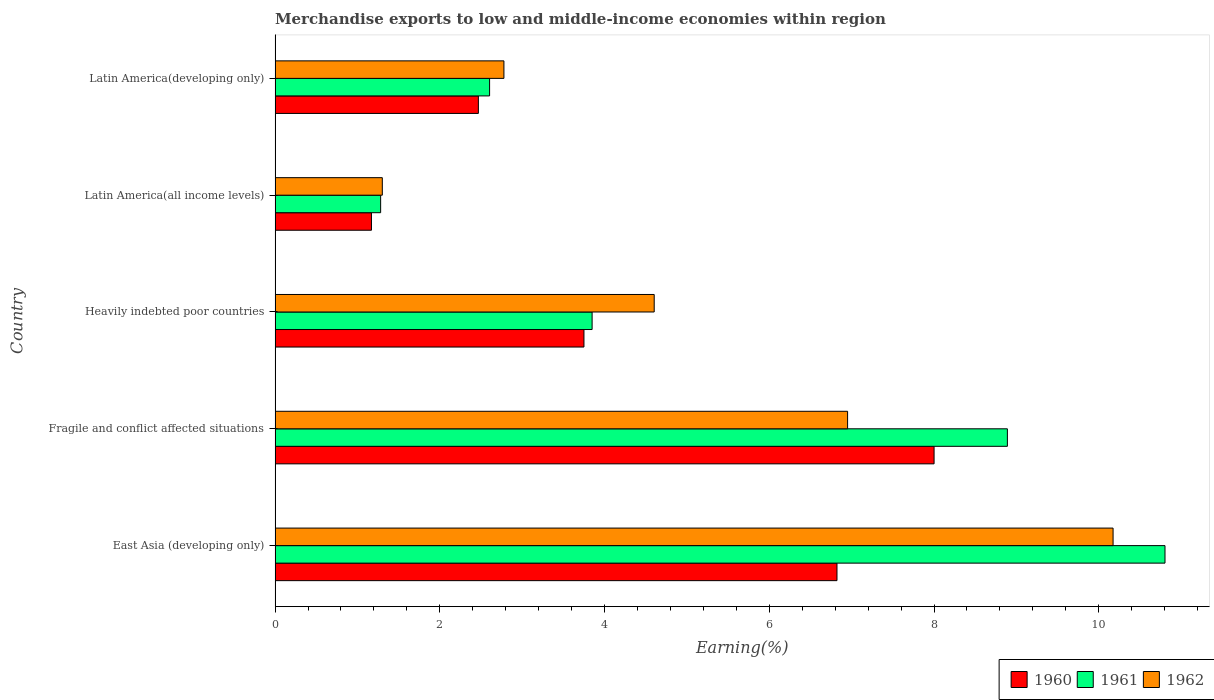How many different coloured bars are there?
Your answer should be compact. 3. How many bars are there on the 2nd tick from the bottom?
Make the answer very short. 3. What is the label of the 3rd group of bars from the top?
Your answer should be very brief. Heavily indebted poor countries. In how many cases, is the number of bars for a given country not equal to the number of legend labels?
Your response must be concise. 0. What is the percentage of amount earned from merchandise exports in 1961 in East Asia (developing only)?
Provide a succinct answer. 10.8. Across all countries, what is the maximum percentage of amount earned from merchandise exports in 1960?
Your answer should be compact. 8. Across all countries, what is the minimum percentage of amount earned from merchandise exports in 1960?
Your answer should be very brief. 1.17. In which country was the percentage of amount earned from merchandise exports in 1962 maximum?
Your response must be concise. East Asia (developing only). In which country was the percentage of amount earned from merchandise exports in 1960 minimum?
Your answer should be compact. Latin America(all income levels). What is the total percentage of amount earned from merchandise exports in 1962 in the graph?
Provide a succinct answer. 25.81. What is the difference between the percentage of amount earned from merchandise exports in 1960 in Latin America(all income levels) and that in Latin America(developing only)?
Give a very brief answer. -1.3. What is the difference between the percentage of amount earned from merchandise exports in 1962 in Heavily indebted poor countries and the percentage of amount earned from merchandise exports in 1961 in East Asia (developing only)?
Give a very brief answer. -6.2. What is the average percentage of amount earned from merchandise exports in 1960 per country?
Give a very brief answer. 4.44. What is the difference between the percentage of amount earned from merchandise exports in 1960 and percentage of amount earned from merchandise exports in 1961 in Fragile and conflict affected situations?
Your response must be concise. -0.89. What is the ratio of the percentage of amount earned from merchandise exports in 1962 in Fragile and conflict affected situations to that in Latin America(all income levels)?
Your response must be concise. 5.34. Is the percentage of amount earned from merchandise exports in 1960 in Heavily indebted poor countries less than that in Latin America(developing only)?
Your answer should be compact. No. What is the difference between the highest and the second highest percentage of amount earned from merchandise exports in 1961?
Offer a very short reply. 1.91. What is the difference between the highest and the lowest percentage of amount earned from merchandise exports in 1960?
Make the answer very short. 6.83. Is the sum of the percentage of amount earned from merchandise exports in 1962 in Heavily indebted poor countries and Latin America(developing only) greater than the maximum percentage of amount earned from merchandise exports in 1960 across all countries?
Offer a terse response. No. What does the 3rd bar from the top in Latin America(developing only) represents?
Keep it short and to the point. 1960. How many bars are there?
Provide a succinct answer. 15. Are the values on the major ticks of X-axis written in scientific E-notation?
Your answer should be compact. No. How many legend labels are there?
Keep it short and to the point. 3. How are the legend labels stacked?
Your answer should be compact. Horizontal. What is the title of the graph?
Offer a very short reply. Merchandise exports to low and middle-income economies within region. What is the label or title of the X-axis?
Ensure brevity in your answer.  Earning(%). What is the label or title of the Y-axis?
Offer a very short reply. Country. What is the Earning(%) of 1960 in East Asia (developing only)?
Make the answer very short. 6.82. What is the Earning(%) of 1961 in East Asia (developing only)?
Keep it short and to the point. 10.8. What is the Earning(%) in 1962 in East Asia (developing only)?
Keep it short and to the point. 10.17. What is the Earning(%) in 1960 in Fragile and conflict affected situations?
Give a very brief answer. 8. What is the Earning(%) of 1961 in Fragile and conflict affected situations?
Keep it short and to the point. 8.89. What is the Earning(%) in 1962 in Fragile and conflict affected situations?
Your answer should be compact. 6.95. What is the Earning(%) of 1960 in Heavily indebted poor countries?
Give a very brief answer. 3.75. What is the Earning(%) in 1961 in Heavily indebted poor countries?
Provide a short and direct response. 3.85. What is the Earning(%) in 1962 in Heavily indebted poor countries?
Keep it short and to the point. 4.6. What is the Earning(%) in 1960 in Latin America(all income levels)?
Provide a succinct answer. 1.17. What is the Earning(%) of 1961 in Latin America(all income levels)?
Offer a very short reply. 1.28. What is the Earning(%) of 1962 in Latin America(all income levels)?
Offer a very short reply. 1.3. What is the Earning(%) in 1960 in Latin America(developing only)?
Your answer should be very brief. 2.47. What is the Earning(%) in 1961 in Latin America(developing only)?
Make the answer very short. 2.6. What is the Earning(%) in 1962 in Latin America(developing only)?
Give a very brief answer. 2.78. Across all countries, what is the maximum Earning(%) of 1960?
Your response must be concise. 8. Across all countries, what is the maximum Earning(%) of 1961?
Offer a very short reply. 10.8. Across all countries, what is the maximum Earning(%) in 1962?
Offer a terse response. 10.17. Across all countries, what is the minimum Earning(%) in 1960?
Provide a short and direct response. 1.17. Across all countries, what is the minimum Earning(%) in 1961?
Provide a short and direct response. 1.28. Across all countries, what is the minimum Earning(%) of 1962?
Offer a terse response. 1.3. What is the total Earning(%) of 1960 in the graph?
Your answer should be very brief. 22.21. What is the total Earning(%) in 1961 in the graph?
Ensure brevity in your answer.  27.43. What is the total Earning(%) of 1962 in the graph?
Offer a very short reply. 25.81. What is the difference between the Earning(%) in 1960 in East Asia (developing only) and that in Fragile and conflict affected situations?
Keep it short and to the point. -1.18. What is the difference between the Earning(%) of 1961 in East Asia (developing only) and that in Fragile and conflict affected situations?
Provide a succinct answer. 1.91. What is the difference between the Earning(%) of 1962 in East Asia (developing only) and that in Fragile and conflict affected situations?
Your response must be concise. 3.22. What is the difference between the Earning(%) of 1960 in East Asia (developing only) and that in Heavily indebted poor countries?
Provide a succinct answer. 3.07. What is the difference between the Earning(%) in 1961 in East Asia (developing only) and that in Heavily indebted poor countries?
Offer a terse response. 6.96. What is the difference between the Earning(%) of 1962 in East Asia (developing only) and that in Heavily indebted poor countries?
Make the answer very short. 5.57. What is the difference between the Earning(%) of 1960 in East Asia (developing only) and that in Latin America(all income levels)?
Your response must be concise. 5.65. What is the difference between the Earning(%) of 1961 in East Asia (developing only) and that in Latin America(all income levels)?
Your answer should be very brief. 9.52. What is the difference between the Earning(%) of 1962 in East Asia (developing only) and that in Latin America(all income levels)?
Ensure brevity in your answer.  8.87. What is the difference between the Earning(%) of 1960 in East Asia (developing only) and that in Latin America(developing only)?
Offer a terse response. 4.35. What is the difference between the Earning(%) in 1961 in East Asia (developing only) and that in Latin America(developing only)?
Offer a terse response. 8.2. What is the difference between the Earning(%) in 1962 in East Asia (developing only) and that in Latin America(developing only)?
Offer a terse response. 7.4. What is the difference between the Earning(%) of 1960 in Fragile and conflict affected situations and that in Heavily indebted poor countries?
Provide a short and direct response. 4.25. What is the difference between the Earning(%) in 1961 in Fragile and conflict affected situations and that in Heavily indebted poor countries?
Your response must be concise. 5.04. What is the difference between the Earning(%) of 1962 in Fragile and conflict affected situations and that in Heavily indebted poor countries?
Keep it short and to the point. 2.35. What is the difference between the Earning(%) of 1960 in Fragile and conflict affected situations and that in Latin America(all income levels)?
Ensure brevity in your answer.  6.83. What is the difference between the Earning(%) of 1961 in Fragile and conflict affected situations and that in Latin America(all income levels)?
Your answer should be very brief. 7.61. What is the difference between the Earning(%) in 1962 in Fragile and conflict affected situations and that in Latin America(all income levels)?
Your response must be concise. 5.65. What is the difference between the Earning(%) in 1960 in Fragile and conflict affected situations and that in Latin America(developing only)?
Make the answer very short. 5.53. What is the difference between the Earning(%) in 1961 in Fragile and conflict affected situations and that in Latin America(developing only)?
Ensure brevity in your answer.  6.29. What is the difference between the Earning(%) of 1962 in Fragile and conflict affected situations and that in Latin America(developing only)?
Your answer should be very brief. 4.17. What is the difference between the Earning(%) in 1960 in Heavily indebted poor countries and that in Latin America(all income levels)?
Provide a succinct answer. 2.58. What is the difference between the Earning(%) of 1961 in Heavily indebted poor countries and that in Latin America(all income levels)?
Offer a terse response. 2.57. What is the difference between the Earning(%) of 1962 in Heavily indebted poor countries and that in Latin America(all income levels)?
Offer a terse response. 3.3. What is the difference between the Earning(%) of 1960 in Heavily indebted poor countries and that in Latin America(developing only)?
Your response must be concise. 1.28. What is the difference between the Earning(%) of 1961 in Heavily indebted poor countries and that in Latin America(developing only)?
Ensure brevity in your answer.  1.24. What is the difference between the Earning(%) of 1962 in Heavily indebted poor countries and that in Latin America(developing only)?
Provide a short and direct response. 1.82. What is the difference between the Earning(%) in 1960 in Latin America(all income levels) and that in Latin America(developing only)?
Provide a short and direct response. -1.3. What is the difference between the Earning(%) of 1961 in Latin America(all income levels) and that in Latin America(developing only)?
Your response must be concise. -1.32. What is the difference between the Earning(%) in 1962 in Latin America(all income levels) and that in Latin America(developing only)?
Your answer should be very brief. -1.48. What is the difference between the Earning(%) of 1960 in East Asia (developing only) and the Earning(%) of 1961 in Fragile and conflict affected situations?
Offer a very short reply. -2.07. What is the difference between the Earning(%) in 1960 in East Asia (developing only) and the Earning(%) in 1962 in Fragile and conflict affected situations?
Offer a very short reply. -0.13. What is the difference between the Earning(%) in 1961 in East Asia (developing only) and the Earning(%) in 1962 in Fragile and conflict affected situations?
Your response must be concise. 3.85. What is the difference between the Earning(%) of 1960 in East Asia (developing only) and the Earning(%) of 1961 in Heavily indebted poor countries?
Your response must be concise. 2.97. What is the difference between the Earning(%) of 1960 in East Asia (developing only) and the Earning(%) of 1962 in Heavily indebted poor countries?
Give a very brief answer. 2.22. What is the difference between the Earning(%) in 1961 in East Asia (developing only) and the Earning(%) in 1962 in Heavily indebted poor countries?
Provide a succinct answer. 6.2. What is the difference between the Earning(%) of 1960 in East Asia (developing only) and the Earning(%) of 1961 in Latin America(all income levels)?
Ensure brevity in your answer.  5.54. What is the difference between the Earning(%) in 1960 in East Asia (developing only) and the Earning(%) in 1962 in Latin America(all income levels)?
Ensure brevity in your answer.  5.52. What is the difference between the Earning(%) of 1961 in East Asia (developing only) and the Earning(%) of 1962 in Latin America(all income levels)?
Your response must be concise. 9.5. What is the difference between the Earning(%) of 1960 in East Asia (developing only) and the Earning(%) of 1961 in Latin America(developing only)?
Your response must be concise. 4.22. What is the difference between the Earning(%) of 1960 in East Asia (developing only) and the Earning(%) of 1962 in Latin America(developing only)?
Give a very brief answer. 4.04. What is the difference between the Earning(%) of 1961 in East Asia (developing only) and the Earning(%) of 1962 in Latin America(developing only)?
Provide a succinct answer. 8.03. What is the difference between the Earning(%) of 1960 in Fragile and conflict affected situations and the Earning(%) of 1961 in Heavily indebted poor countries?
Offer a very short reply. 4.15. What is the difference between the Earning(%) of 1960 in Fragile and conflict affected situations and the Earning(%) of 1962 in Heavily indebted poor countries?
Your answer should be very brief. 3.4. What is the difference between the Earning(%) in 1961 in Fragile and conflict affected situations and the Earning(%) in 1962 in Heavily indebted poor countries?
Your response must be concise. 4.29. What is the difference between the Earning(%) in 1960 in Fragile and conflict affected situations and the Earning(%) in 1961 in Latin America(all income levels)?
Offer a terse response. 6.72. What is the difference between the Earning(%) in 1960 in Fragile and conflict affected situations and the Earning(%) in 1962 in Latin America(all income levels)?
Your response must be concise. 6.7. What is the difference between the Earning(%) of 1961 in Fragile and conflict affected situations and the Earning(%) of 1962 in Latin America(all income levels)?
Keep it short and to the point. 7.59. What is the difference between the Earning(%) in 1960 in Fragile and conflict affected situations and the Earning(%) in 1961 in Latin America(developing only)?
Make the answer very short. 5.4. What is the difference between the Earning(%) of 1960 in Fragile and conflict affected situations and the Earning(%) of 1962 in Latin America(developing only)?
Your answer should be very brief. 5.22. What is the difference between the Earning(%) of 1961 in Fragile and conflict affected situations and the Earning(%) of 1962 in Latin America(developing only)?
Ensure brevity in your answer.  6.11. What is the difference between the Earning(%) in 1960 in Heavily indebted poor countries and the Earning(%) in 1961 in Latin America(all income levels)?
Keep it short and to the point. 2.47. What is the difference between the Earning(%) in 1960 in Heavily indebted poor countries and the Earning(%) in 1962 in Latin America(all income levels)?
Offer a terse response. 2.45. What is the difference between the Earning(%) in 1961 in Heavily indebted poor countries and the Earning(%) in 1962 in Latin America(all income levels)?
Offer a terse response. 2.55. What is the difference between the Earning(%) of 1960 in Heavily indebted poor countries and the Earning(%) of 1961 in Latin America(developing only)?
Ensure brevity in your answer.  1.15. What is the difference between the Earning(%) of 1960 in Heavily indebted poor countries and the Earning(%) of 1962 in Latin America(developing only)?
Your answer should be compact. 0.97. What is the difference between the Earning(%) of 1961 in Heavily indebted poor countries and the Earning(%) of 1962 in Latin America(developing only)?
Make the answer very short. 1.07. What is the difference between the Earning(%) in 1960 in Latin America(all income levels) and the Earning(%) in 1961 in Latin America(developing only)?
Provide a succinct answer. -1.43. What is the difference between the Earning(%) of 1960 in Latin America(all income levels) and the Earning(%) of 1962 in Latin America(developing only)?
Keep it short and to the point. -1.61. What is the difference between the Earning(%) of 1961 in Latin America(all income levels) and the Earning(%) of 1962 in Latin America(developing only)?
Provide a short and direct response. -1.5. What is the average Earning(%) of 1960 per country?
Give a very brief answer. 4.44. What is the average Earning(%) in 1961 per country?
Keep it short and to the point. 5.49. What is the average Earning(%) of 1962 per country?
Your response must be concise. 5.16. What is the difference between the Earning(%) in 1960 and Earning(%) in 1961 in East Asia (developing only)?
Offer a very short reply. -3.98. What is the difference between the Earning(%) of 1960 and Earning(%) of 1962 in East Asia (developing only)?
Ensure brevity in your answer.  -3.35. What is the difference between the Earning(%) of 1961 and Earning(%) of 1962 in East Asia (developing only)?
Offer a very short reply. 0.63. What is the difference between the Earning(%) of 1960 and Earning(%) of 1961 in Fragile and conflict affected situations?
Your answer should be compact. -0.89. What is the difference between the Earning(%) in 1960 and Earning(%) in 1962 in Fragile and conflict affected situations?
Keep it short and to the point. 1.05. What is the difference between the Earning(%) in 1961 and Earning(%) in 1962 in Fragile and conflict affected situations?
Provide a short and direct response. 1.94. What is the difference between the Earning(%) in 1960 and Earning(%) in 1961 in Heavily indebted poor countries?
Keep it short and to the point. -0.1. What is the difference between the Earning(%) in 1960 and Earning(%) in 1962 in Heavily indebted poor countries?
Provide a succinct answer. -0.85. What is the difference between the Earning(%) of 1961 and Earning(%) of 1962 in Heavily indebted poor countries?
Your response must be concise. -0.75. What is the difference between the Earning(%) of 1960 and Earning(%) of 1961 in Latin America(all income levels)?
Your response must be concise. -0.11. What is the difference between the Earning(%) in 1960 and Earning(%) in 1962 in Latin America(all income levels)?
Provide a short and direct response. -0.13. What is the difference between the Earning(%) in 1961 and Earning(%) in 1962 in Latin America(all income levels)?
Your answer should be compact. -0.02. What is the difference between the Earning(%) of 1960 and Earning(%) of 1961 in Latin America(developing only)?
Offer a very short reply. -0.14. What is the difference between the Earning(%) of 1960 and Earning(%) of 1962 in Latin America(developing only)?
Give a very brief answer. -0.31. What is the difference between the Earning(%) of 1961 and Earning(%) of 1962 in Latin America(developing only)?
Make the answer very short. -0.17. What is the ratio of the Earning(%) in 1960 in East Asia (developing only) to that in Fragile and conflict affected situations?
Provide a succinct answer. 0.85. What is the ratio of the Earning(%) of 1961 in East Asia (developing only) to that in Fragile and conflict affected situations?
Offer a very short reply. 1.22. What is the ratio of the Earning(%) in 1962 in East Asia (developing only) to that in Fragile and conflict affected situations?
Offer a terse response. 1.46. What is the ratio of the Earning(%) in 1960 in East Asia (developing only) to that in Heavily indebted poor countries?
Keep it short and to the point. 1.82. What is the ratio of the Earning(%) of 1961 in East Asia (developing only) to that in Heavily indebted poor countries?
Provide a short and direct response. 2.81. What is the ratio of the Earning(%) in 1962 in East Asia (developing only) to that in Heavily indebted poor countries?
Make the answer very short. 2.21. What is the ratio of the Earning(%) in 1960 in East Asia (developing only) to that in Latin America(all income levels)?
Keep it short and to the point. 5.83. What is the ratio of the Earning(%) in 1961 in East Asia (developing only) to that in Latin America(all income levels)?
Your answer should be compact. 8.43. What is the ratio of the Earning(%) of 1962 in East Asia (developing only) to that in Latin America(all income levels)?
Provide a succinct answer. 7.81. What is the ratio of the Earning(%) of 1960 in East Asia (developing only) to that in Latin America(developing only)?
Ensure brevity in your answer.  2.76. What is the ratio of the Earning(%) in 1961 in East Asia (developing only) to that in Latin America(developing only)?
Keep it short and to the point. 4.15. What is the ratio of the Earning(%) of 1962 in East Asia (developing only) to that in Latin America(developing only)?
Ensure brevity in your answer.  3.66. What is the ratio of the Earning(%) in 1960 in Fragile and conflict affected situations to that in Heavily indebted poor countries?
Your answer should be compact. 2.13. What is the ratio of the Earning(%) in 1961 in Fragile and conflict affected situations to that in Heavily indebted poor countries?
Provide a succinct answer. 2.31. What is the ratio of the Earning(%) of 1962 in Fragile and conflict affected situations to that in Heavily indebted poor countries?
Give a very brief answer. 1.51. What is the ratio of the Earning(%) in 1960 in Fragile and conflict affected situations to that in Latin America(all income levels)?
Your answer should be very brief. 6.84. What is the ratio of the Earning(%) in 1961 in Fragile and conflict affected situations to that in Latin America(all income levels)?
Make the answer very short. 6.94. What is the ratio of the Earning(%) in 1962 in Fragile and conflict affected situations to that in Latin America(all income levels)?
Offer a very short reply. 5.34. What is the ratio of the Earning(%) in 1960 in Fragile and conflict affected situations to that in Latin America(developing only)?
Ensure brevity in your answer.  3.24. What is the ratio of the Earning(%) in 1961 in Fragile and conflict affected situations to that in Latin America(developing only)?
Provide a succinct answer. 3.41. What is the ratio of the Earning(%) of 1962 in Fragile and conflict affected situations to that in Latin America(developing only)?
Offer a terse response. 2.5. What is the ratio of the Earning(%) in 1960 in Heavily indebted poor countries to that in Latin America(all income levels)?
Give a very brief answer. 3.2. What is the ratio of the Earning(%) in 1961 in Heavily indebted poor countries to that in Latin America(all income levels)?
Provide a succinct answer. 3. What is the ratio of the Earning(%) of 1962 in Heavily indebted poor countries to that in Latin America(all income levels)?
Your answer should be compact. 3.54. What is the ratio of the Earning(%) of 1960 in Heavily indebted poor countries to that in Latin America(developing only)?
Provide a short and direct response. 1.52. What is the ratio of the Earning(%) in 1961 in Heavily indebted poor countries to that in Latin America(developing only)?
Give a very brief answer. 1.48. What is the ratio of the Earning(%) of 1962 in Heavily indebted poor countries to that in Latin America(developing only)?
Ensure brevity in your answer.  1.66. What is the ratio of the Earning(%) in 1960 in Latin America(all income levels) to that in Latin America(developing only)?
Your answer should be compact. 0.47. What is the ratio of the Earning(%) of 1961 in Latin America(all income levels) to that in Latin America(developing only)?
Your answer should be very brief. 0.49. What is the ratio of the Earning(%) of 1962 in Latin America(all income levels) to that in Latin America(developing only)?
Ensure brevity in your answer.  0.47. What is the difference between the highest and the second highest Earning(%) of 1960?
Offer a very short reply. 1.18. What is the difference between the highest and the second highest Earning(%) of 1961?
Offer a terse response. 1.91. What is the difference between the highest and the second highest Earning(%) in 1962?
Your answer should be compact. 3.22. What is the difference between the highest and the lowest Earning(%) in 1960?
Offer a terse response. 6.83. What is the difference between the highest and the lowest Earning(%) in 1961?
Give a very brief answer. 9.52. What is the difference between the highest and the lowest Earning(%) in 1962?
Provide a succinct answer. 8.87. 